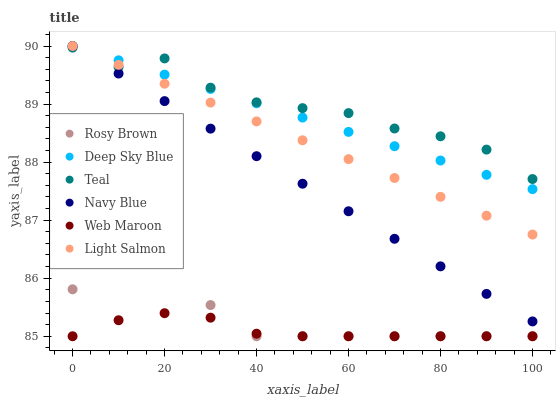Does Web Maroon have the minimum area under the curve?
Answer yes or no. Yes. Does Teal have the maximum area under the curve?
Answer yes or no. Yes. Does Deep Sky Blue have the minimum area under the curve?
Answer yes or no. No. Does Deep Sky Blue have the maximum area under the curve?
Answer yes or no. No. Is Light Salmon the smoothest?
Answer yes or no. Yes. Is Rosy Brown the roughest?
Answer yes or no. Yes. Is Deep Sky Blue the smoothest?
Answer yes or no. No. Is Deep Sky Blue the roughest?
Answer yes or no. No. Does Rosy Brown have the lowest value?
Answer yes or no. Yes. Does Deep Sky Blue have the lowest value?
Answer yes or no. No. Does Navy Blue have the highest value?
Answer yes or no. Yes. Does Rosy Brown have the highest value?
Answer yes or no. No. Is Rosy Brown less than Navy Blue?
Answer yes or no. Yes. Is Deep Sky Blue greater than Rosy Brown?
Answer yes or no. Yes. Does Web Maroon intersect Rosy Brown?
Answer yes or no. Yes. Is Web Maroon less than Rosy Brown?
Answer yes or no. No. Is Web Maroon greater than Rosy Brown?
Answer yes or no. No. Does Rosy Brown intersect Navy Blue?
Answer yes or no. No. 